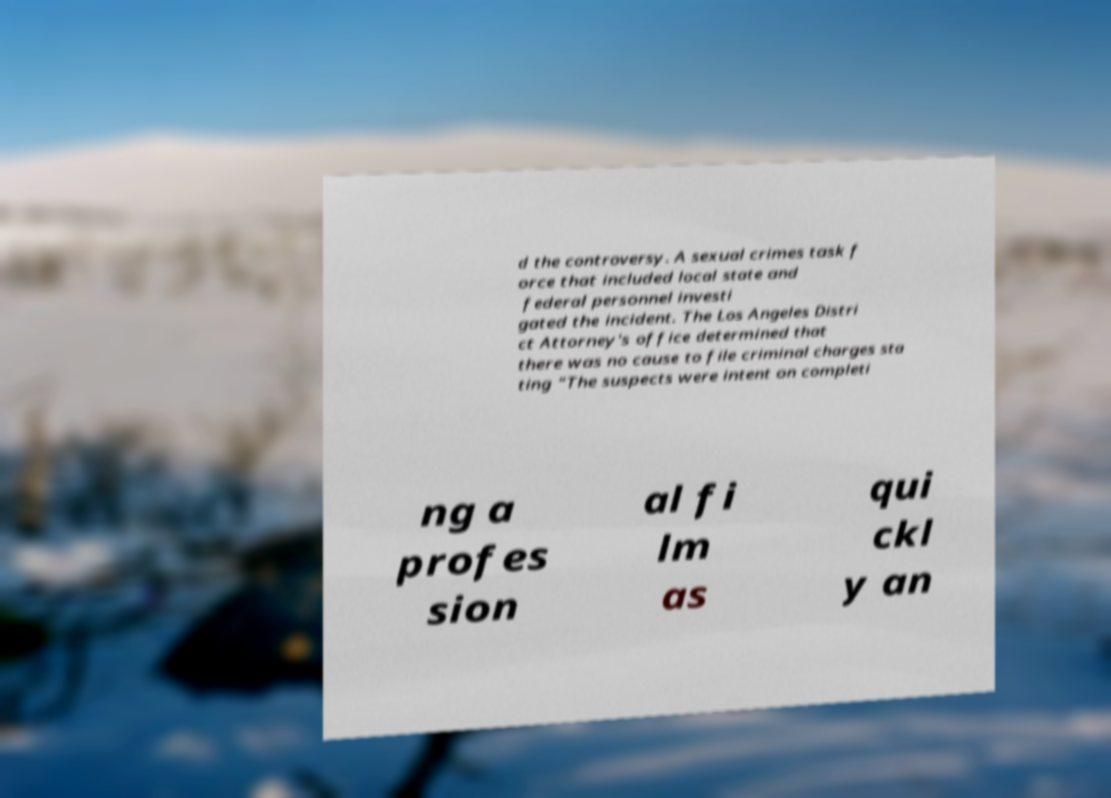What messages or text are displayed in this image? I need them in a readable, typed format. d the controversy. A sexual crimes task f orce that included local state and federal personnel investi gated the incident. The Los Angeles Distri ct Attorney's office determined that there was no cause to file criminal charges sta ting "The suspects were intent on completi ng a profes sion al fi lm as qui ckl y an 